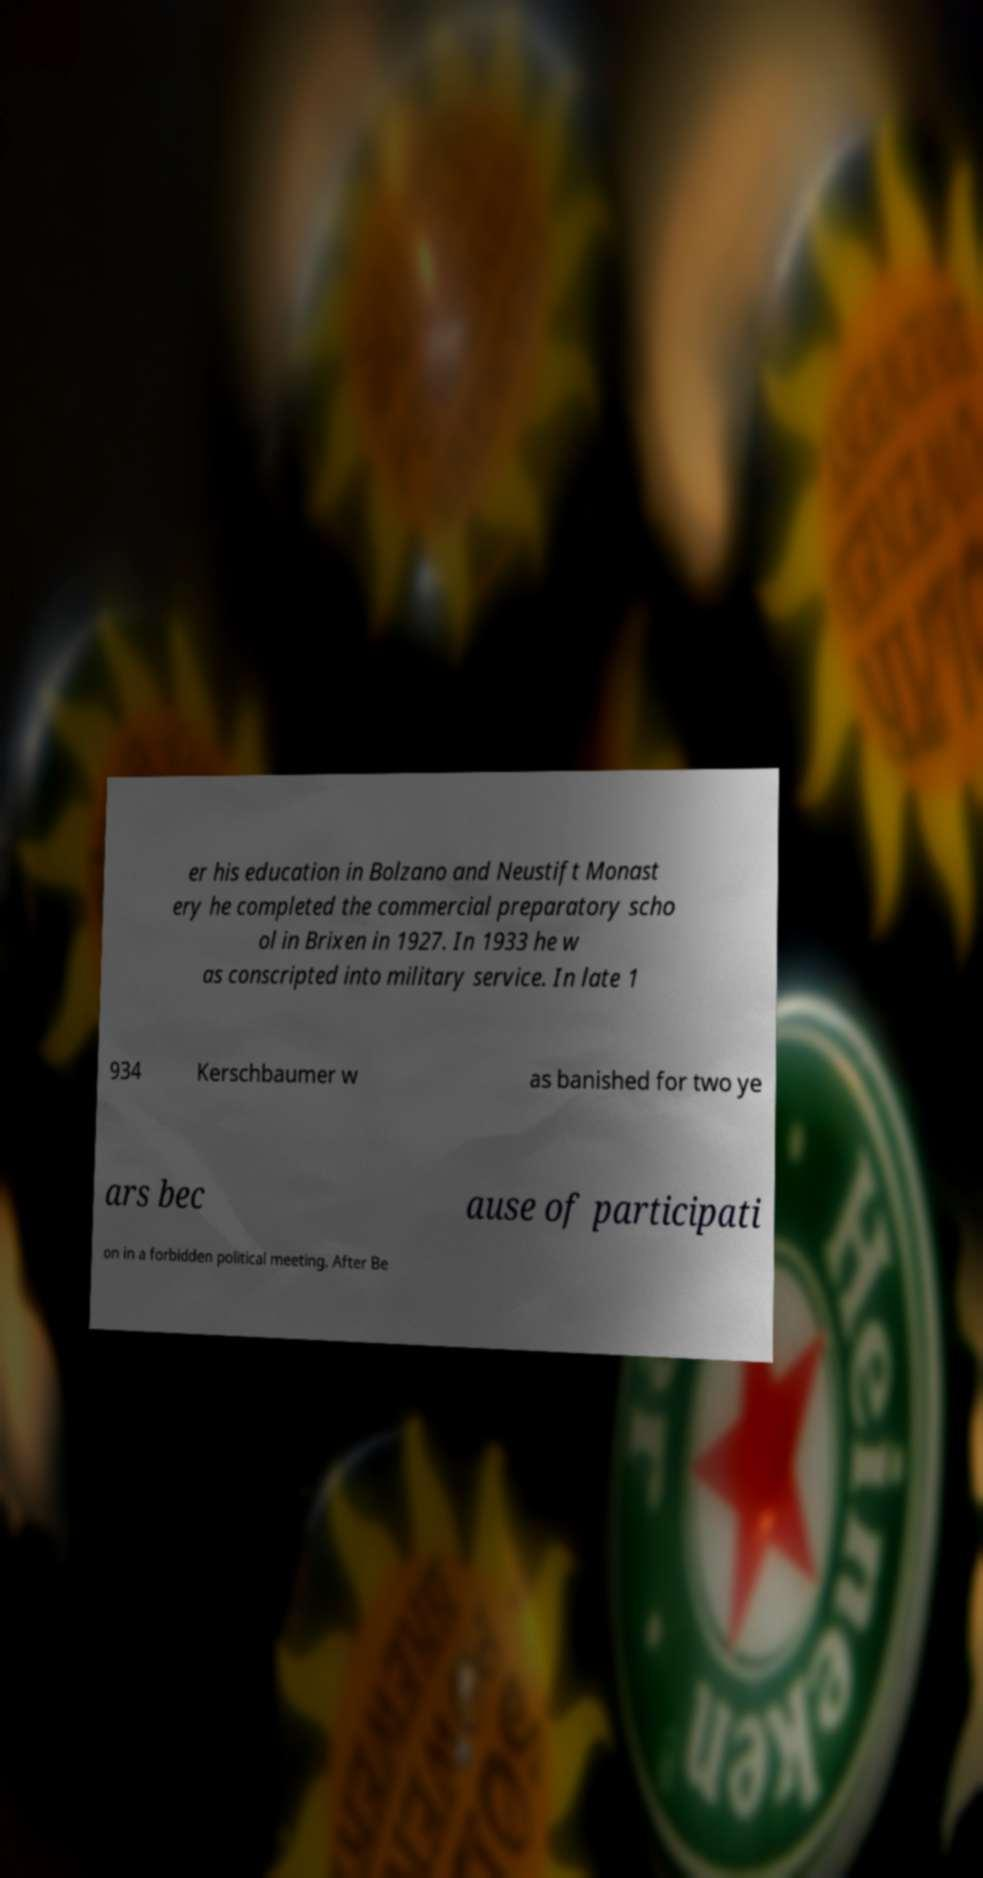For documentation purposes, I need the text within this image transcribed. Could you provide that? er his education in Bolzano and Neustift Monast ery he completed the commercial preparatory scho ol in Brixen in 1927. In 1933 he w as conscripted into military service. In late 1 934 Kerschbaumer w as banished for two ye ars bec ause of participati on in a forbidden political meeting. After Be 